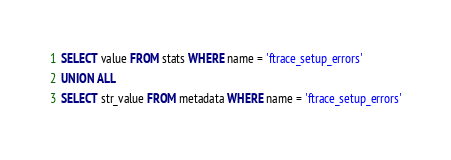<code> <loc_0><loc_0><loc_500><loc_500><_SQL_>SELECT value FROM stats WHERE name = 'ftrace_setup_errors'
UNION ALL
SELECT str_value FROM metadata WHERE name = 'ftrace_setup_errors'
</code> 